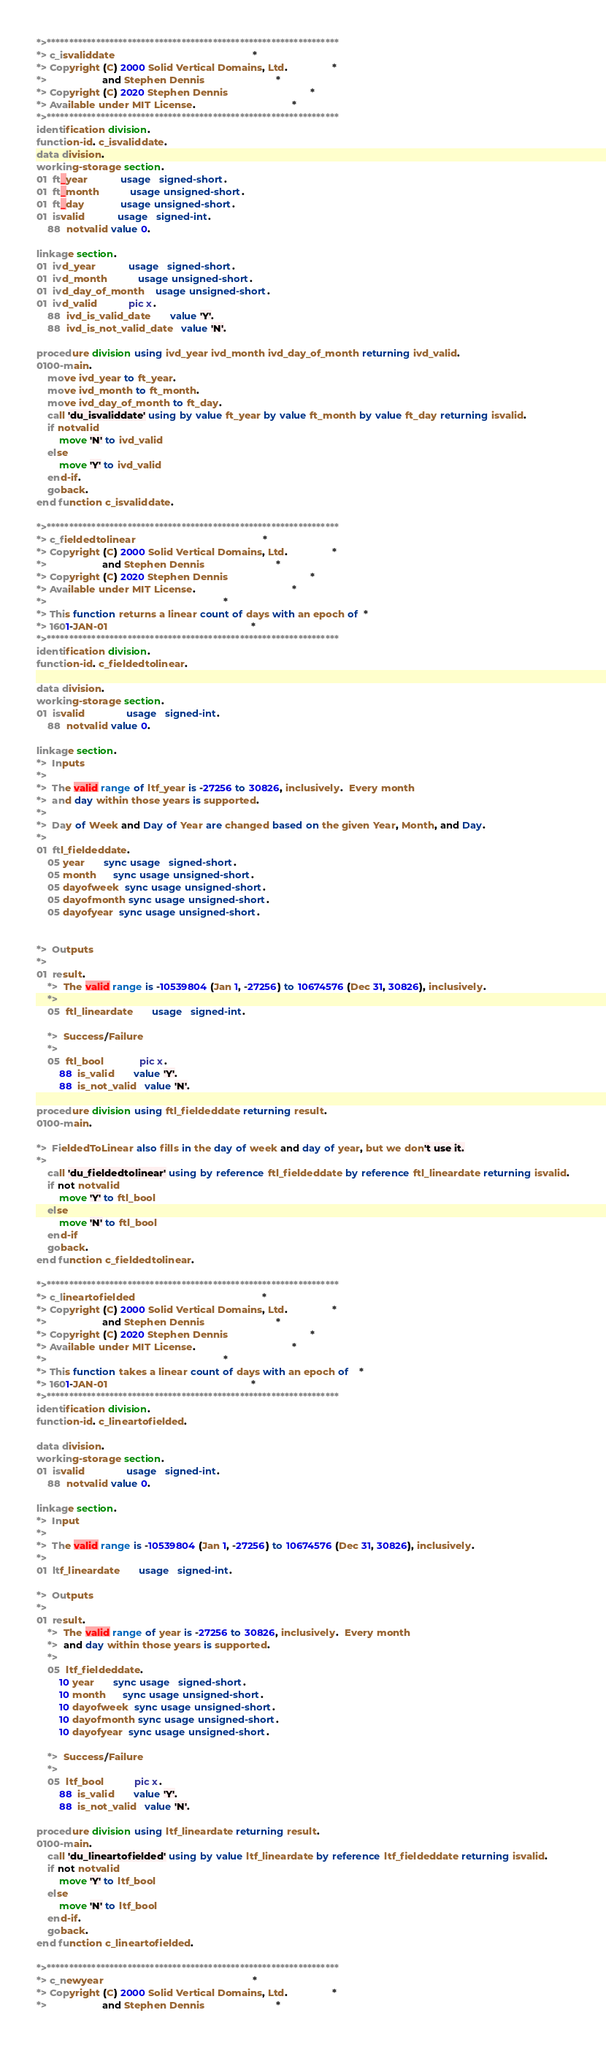<code> <loc_0><loc_0><loc_500><loc_500><_COBOL_>*>*****************************************************************
*> c_isvaliddate                                                  *
*> Copyright (C) 2000 Solid Vertical Domains, Ltd.                *
*>                    and Stephen Dennis                          *
*> Copyright (C) 2020 Stephen Dennis                              *
*> Available under MIT License.                                   *
*>*****************************************************************
identification division.
function-id. c_isvaliddate.
data division.
working-storage section.
01  ft_year            usage   signed-short.
01  ft_month           usage unsigned-short.
01  ft_day             usage unsigned-short.
01  isvalid            usage   signed-int.
    88  notvalid value 0.

linkage section.
01  ivd_year            usage   signed-short.
01  ivd_month           usage unsigned-short.
01  ivd_day_of_month    usage unsigned-short.
01  ivd_valid           pic x.
    88  ivd_is_valid_date       value 'Y'.
    88  ivd_is_not_valid_date   value 'N'.

procedure division using ivd_year ivd_month ivd_day_of_month returning ivd_valid.
0100-main.
    move ivd_year to ft_year.
    move ivd_month to ft_month.
    move ivd_day_of_month to ft_day.
    call 'du_isvaliddate' using by value ft_year by value ft_month by value ft_day returning isvalid.
    if notvalid
        move 'N' to ivd_valid
    else
        move 'Y' to ivd_valid
    end-if.
    goback.
end function c_isvaliddate.

*>*****************************************************************
*> c_fieldedtolinear                                              *
*> Copyright (C) 2000 Solid Vertical Domains, Ltd.                *
*>                    and Stephen Dennis                          *
*> Copyright (C) 2020 Stephen Dennis                              *
*> Available under MIT License.                                   *
*>                                                                *
*> This function returns a linear count of days with an epoch of  *
*> 1601-JAN-01                                                    *
*>*****************************************************************
identification division.
function-id. c_fieldedtolinear.

data division.
working-storage section.
01  isvalid               usage   signed-int.
    88  notvalid value 0.

linkage section.
*>  Inputs
*>
*>  The valid range of ltf_year is -27256 to 30826, inclusively.  Every month
*>  and day within those years is supported.
*>
*>  Day of Week and Day of Year are changed based on the given Year, Month, and Day.
*>
01  ftl_fieldeddate.
    05 year       sync usage   signed-short.
    05 month      sync usage unsigned-short.
    05 dayofweek  sync usage unsigned-short.
    05 dayofmonth sync usage unsigned-short.
    05 dayofyear  sync usage unsigned-short.


*>  Outputs
*>
01  result.
    *>  The valid range is -10539804 (Jan 1, -27256) to 10674576 (Dec 31, 30826), inclusively.
    *>
    05  ftl_lineardate       usage   signed-int.

    *>  Success/Failure
    *>
    05  ftl_bool             pic x.
        88  is_valid       value 'Y'.
        88  is_not_valid   value 'N'.

procedure division using ftl_fieldeddate returning result.
0100-main.

*>  FieldedToLinear also fills in the day of week and day of year, but we don't use it.
*>
    call 'du_fieldedtolinear' using by reference ftl_fieldeddate by reference ftl_lineardate returning isvalid.
    if not notvalid
        move 'Y' to ftl_bool
    else
        move 'N' to ftl_bool
    end-if
    goback.
end function c_fieldedtolinear.

*>*****************************************************************
*> c_lineartofielded                                              *
*> Copyright (C) 2000 Solid Vertical Domains, Ltd.                *
*>                    and Stephen Dennis                          *
*> Copyright (C) 2020 Stephen Dennis                              *
*> Available under MIT License.                                   *
*>                                                                *
*> This function takes a linear count of days with an epoch of    *
*> 1601-JAN-01                                                    *
*>*****************************************************************
identification division.
function-id. c_lineartofielded.

data division.
working-storage section.
01  isvalid               usage   signed-int.
    88  notvalid value 0.

linkage section.
*>  Input
*>
*>  The valid range is -10539804 (Jan 1, -27256) to 10674576 (Dec 31, 30826), inclusively.
*>
01  ltf_lineardate       usage   signed-int.

*>  Outputs
*>
01  result.
    *>  The valid range of year is -27256 to 30826, inclusively.  Every month
    *>  and day within those years is supported.
    *>
    05  ltf_fieldeddate.
        10 year       sync usage   signed-short.
        10 month      sync usage unsigned-short.
        10 dayofweek  sync usage unsigned-short.
        10 dayofmonth sync usage unsigned-short.
        10 dayofyear  sync usage unsigned-short.

    *>  Success/Failure
    *>
    05  ltf_bool           pic x.
        88  is_valid       value 'Y'.
        88  is_not_valid   value 'N'.

procedure division using ltf_lineardate returning result.
0100-main.
    call 'du_lineartofielded' using by value ltf_lineardate by reference ltf_fieldeddate returning isvalid.
    if not notvalid
        move 'Y' to ltf_bool
    else
        move 'N' to ltf_bool
    end-if.
    goback.
end function c_lineartofielded.

*>*****************************************************************
*> c_newyear                                                      *
*> Copyright (C) 2000 Solid Vertical Domains, Ltd.                *
*>                    and Stephen Dennis                          *</code> 